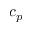<formula> <loc_0><loc_0><loc_500><loc_500>c _ { p }</formula> 